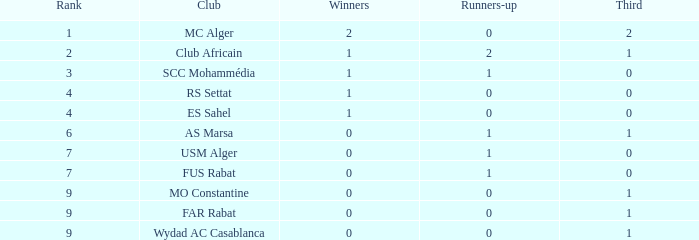Which third contains 0 runners-up, 0 winners, and a club of remote rabat? 1.0. 